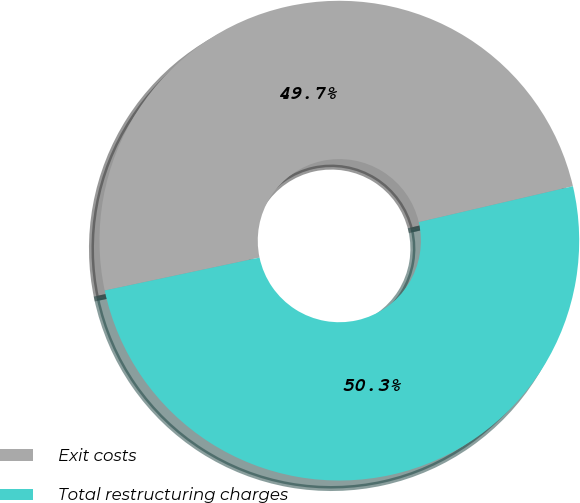Convert chart to OTSL. <chart><loc_0><loc_0><loc_500><loc_500><pie_chart><fcel>Exit costs<fcel>Total restructuring charges<nl><fcel>49.69%<fcel>50.31%<nl></chart> 